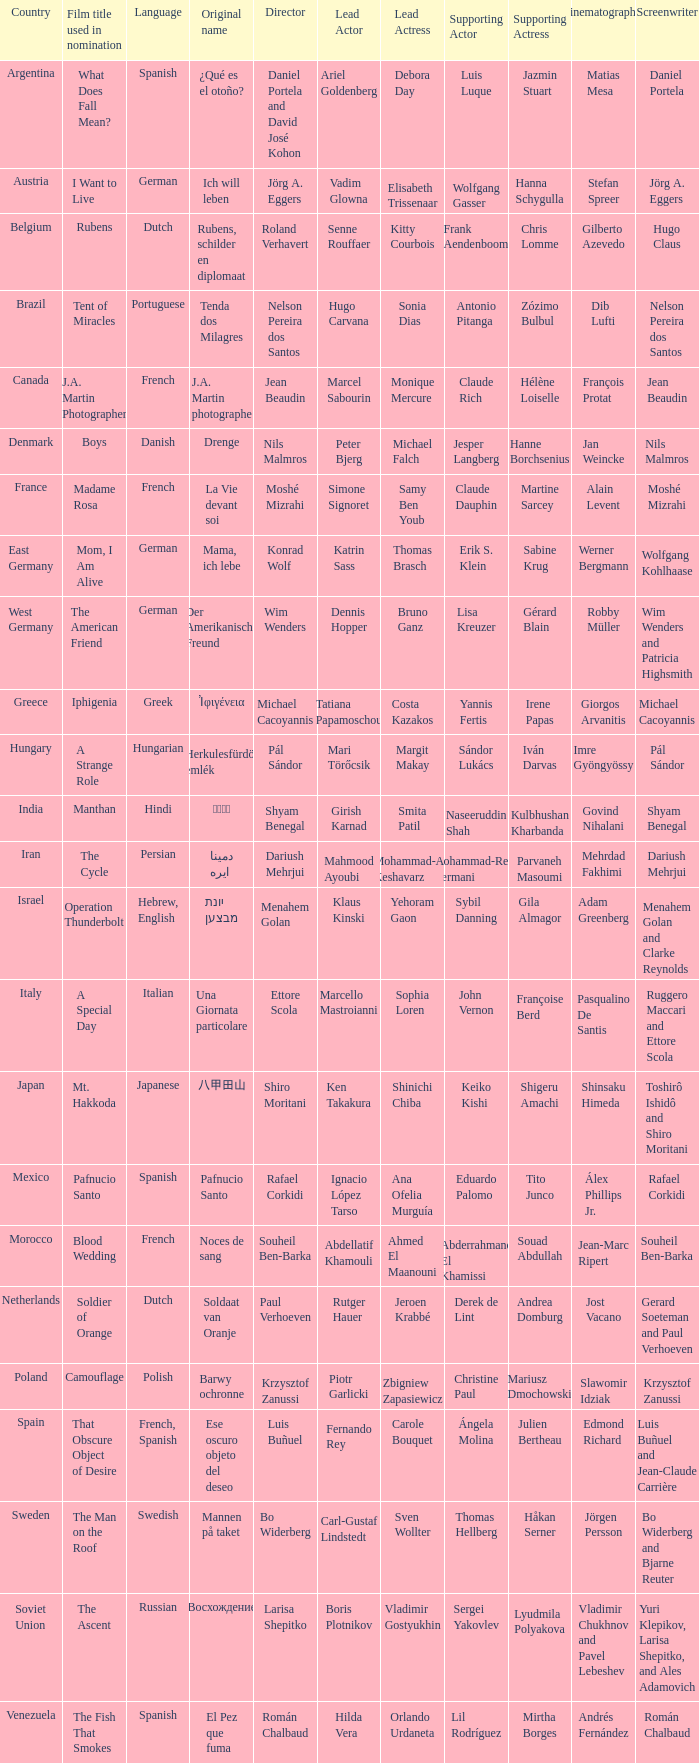What is the title of the German film that is originally called Mama, Ich Lebe? Mom, I Am Alive. 